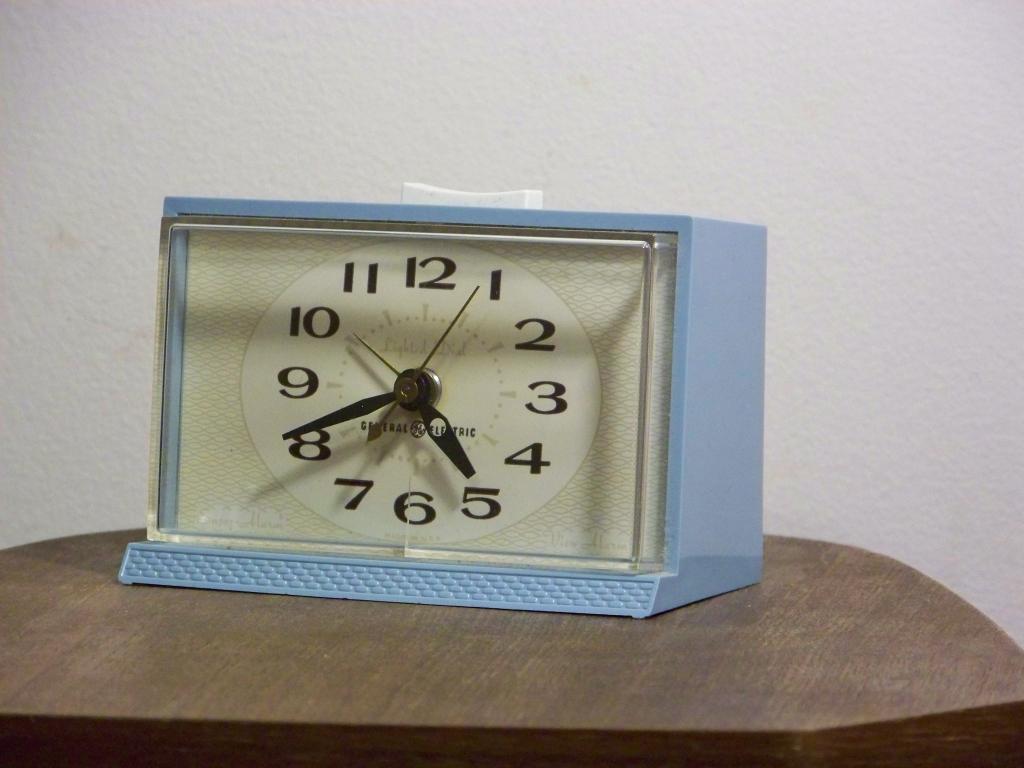What time does the clock read?
Provide a succinct answer. 5:41. What hand is the second hand pointing to?
Your answer should be compact. 8. 